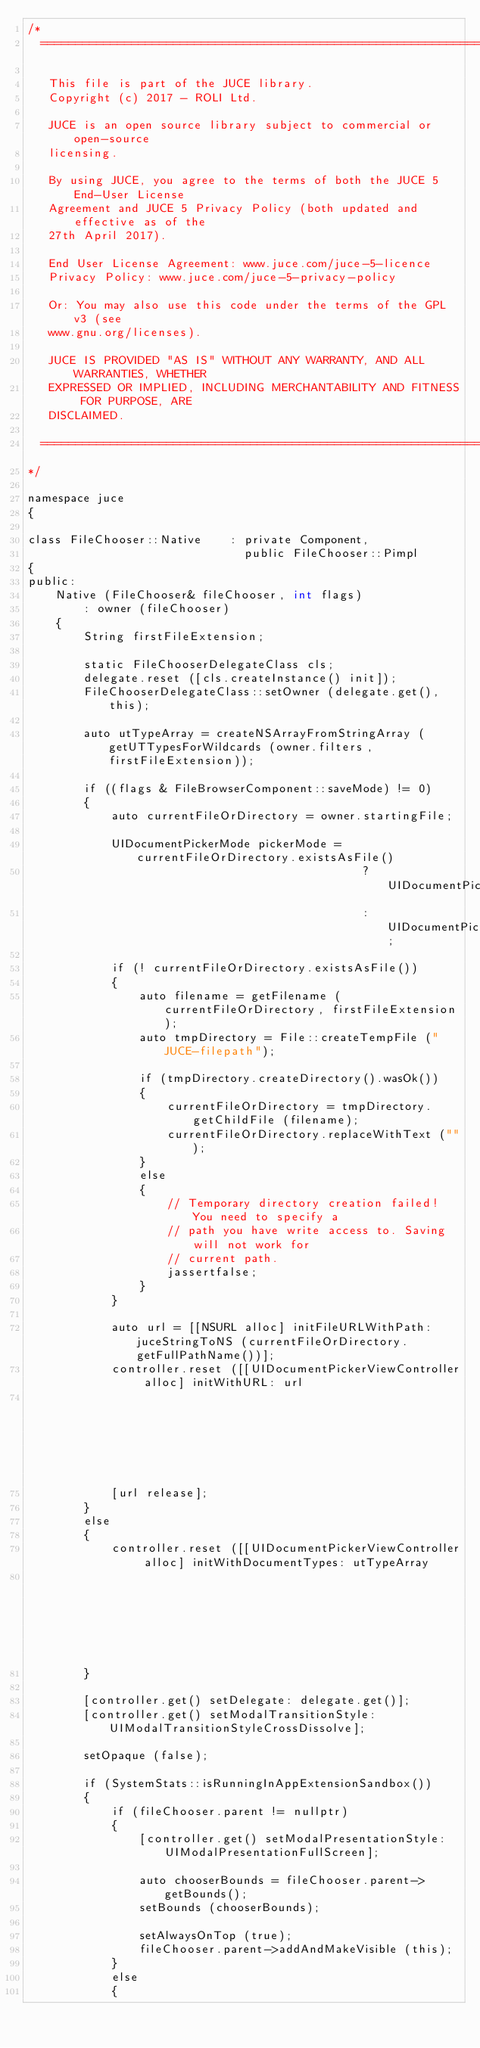Convert code to text. <code><loc_0><loc_0><loc_500><loc_500><_ObjectiveC_>/*
  ==============================================================================

   This file is part of the JUCE library.
   Copyright (c) 2017 - ROLI Ltd.

   JUCE is an open source library subject to commercial or open-source
   licensing.

   By using JUCE, you agree to the terms of both the JUCE 5 End-User License
   Agreement and JUCE 5 Privacy Policy (both updated and effective as of the
   27th April 2017).

   End User License Agreement: www.juce.com/juce-5-licence
   Privacy Policy: www.juce.com/juce-5-privacy-policy

   Or: You may also use this code under the terms of the GPL v3 (see
   www.gnu.org/licenses).

   JUCE IS PROVIDED "AS IS" WITHOUT ANY WARRANTY, AND ALL WARRANTIES, WHETHER
   EXPRESSED OR IMPLIED, INCLUDING MERCHANTABILITY AND FITNESS FOR PURPOSE, ARE
   DISCLAIMED.

  ==============================================================================
*/

namespace juce
{

class FileChooser::Native    : private Component,
                               public FileChooser::Pimpl
{
public:
    Native (FileChooser& fileChooser, int flags)
        : owner (fileChooser)
    {
        String firstFileExtension;

        static FileChooserDelegateClass cls;
        delegate.reset ([cls.createInstance() init]);
        FileChooserDelegateClass::setOwner (delegate.get(), this);

        auto utTypeArray = createNSArrayFromStringArray (getUTTypesForWildcards (owner.filters, firstFileExtension));

        if ((flags & FileBrowserComponent::saveMode) != 0)
        {
            auto currentFileOrDirectory = owner.startingFile;

            UIDocumentPickerMode pickerMode = currentFileOrDirectory.existsAsFile()
                                                ? UIDocumentPickerModeExportToService
                                                : UIDocumentPickerModeMoveToService;

            if (! currentFileOrDirectory.existsAsFile())
            {
                auto filename = getFilename (currentFileOrDirectory, firstFileExtension);
                auto tmpDirectory = File::createTempFile ("JUCE-filepath");

                if (tmpDirectory.createDirectory().wasOk())
                {
                    currentFileOrDirectory = tmpDirectory.getChildFile (filename);
                    currentFileOrDirectory.replaceWithText ("");
                }
                else
                {
                    // Temporary directory creation failed! You need to specify a
                    // path you have write access to. Saving will not work for
                    // current path.
                    jassertfalse;
                }
            }

            auto url = [[NSURL alloc] initFileURLWithPath: juceStringToNS (currentFileOrDirectory.getFullPathName())];
            controller.reset ([[UIDocumentPickerViewController alloc] initWithURL: url
                                                                           inMode: pickerMode]);
            [url release];
        }
        else
        {
            controller.reset ([[UIDocumentPickerViewController alloc] initWithDocumentTypes: utTypeArray
                                                                                      inMode: UIDocumentPickerModeOpen]);
        }

        [controller.get() setDelegate: delegate.get()];
        [controller.get() setModalTransitionStyle: UIModalTransitionStyleCrossDissolve];

        setOpaque (false);

        if (SystemStats::isRunningInAppExtensionSandbox())
        {
            if (fileChooser.parent != nullptr)
            {
                [controller.get() setModalPresentationStyle:UIModalPresentationFullScreen];

                auto chooserBounds = fileChooser.parent->getBounds();
                setBounds (chooserBounds);

                setAlwaysOnTop (true);
                fileChooser.parent->addAndMakeVisible (this);
            }
            else
            {</code> 